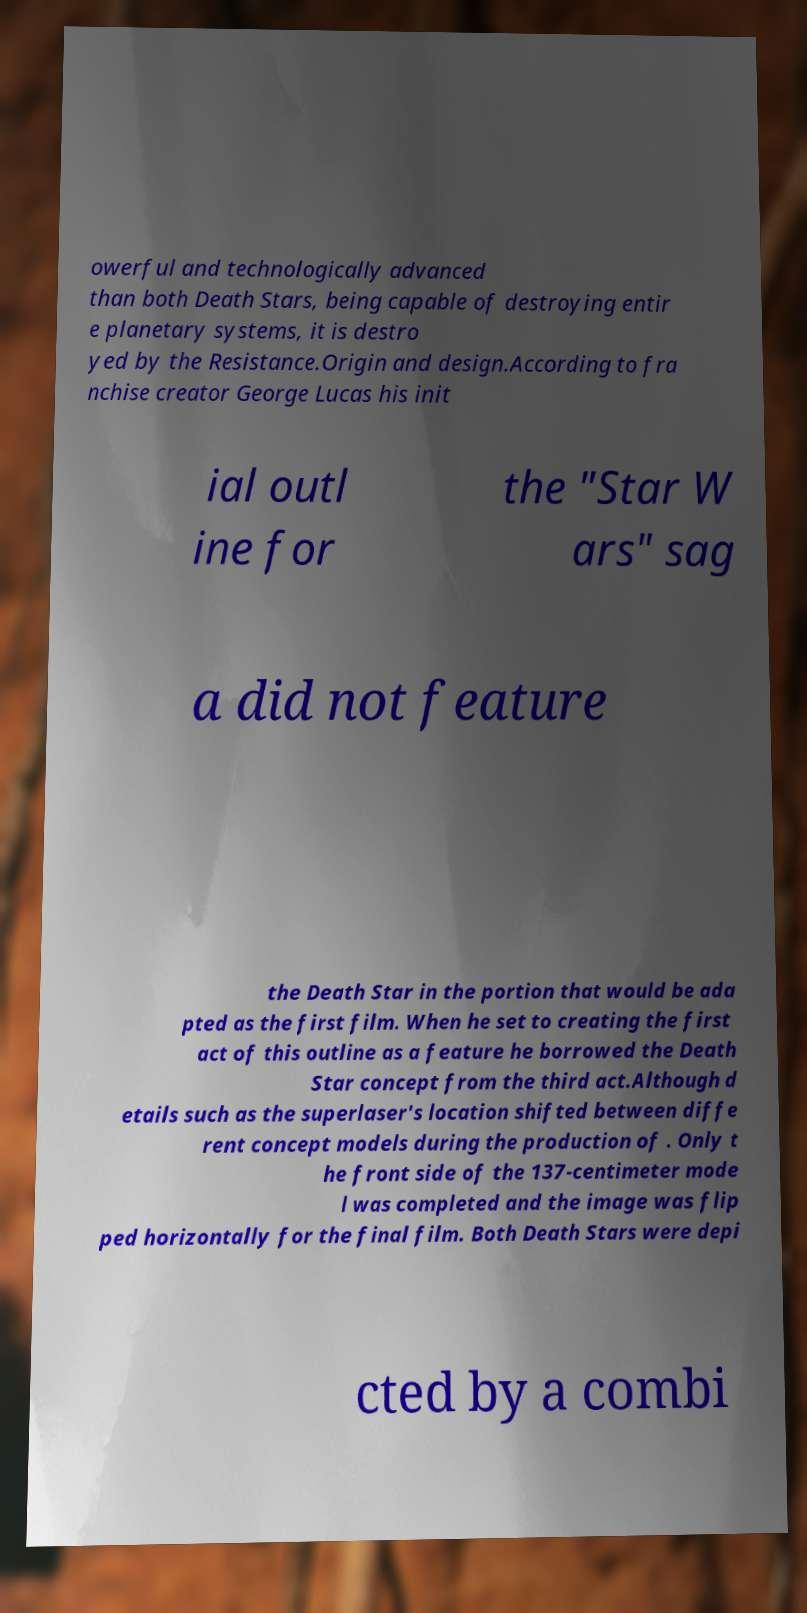There's text embedded in this image that I need extracted. Can you transcribe it verbatim? owerful and technologically advanced than both Death Stars, being capable of destroying entir e planetary systems, it is destro yed by the Resistance.Origin and design.According to fra nchise creator George Lucas his init ial outl ine for the "Star W ars" sag a did not feature the Death Star in the portion that would be ada pted as the first film. When he set to creating the first act of this outline as a feature he borrowed the Death Star concept from the third act.Although d etails such as the superlaser's location shifted between diffe rent concept models during the production of . Only t he front side of the 137-centimeter mode l was completed and the image was flip ped horizontally for the final film. Both Death Stars were depi cted by a combi 